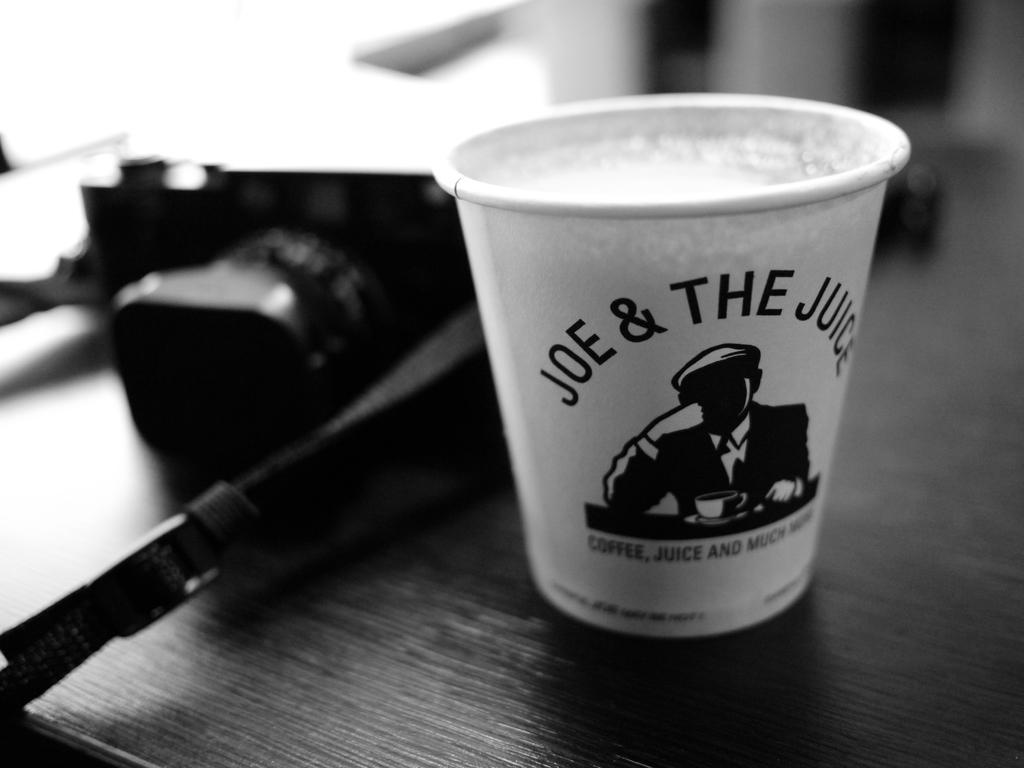<image>
Offer a succinct explanation of the picture presented. A cup from Joe and the Juice sits on a wooden table. 